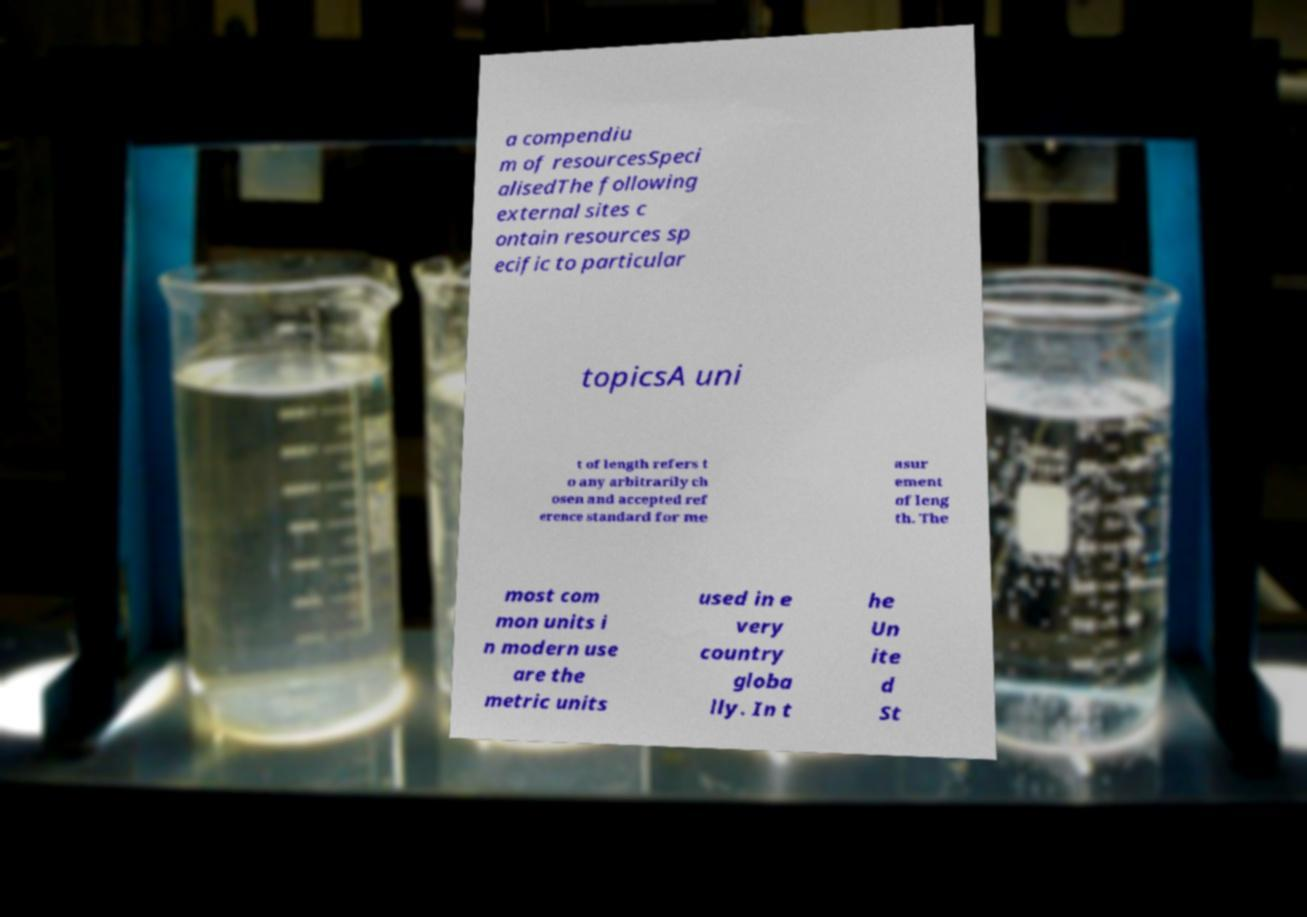What messages or text are displayed in this image? I need them in a readable, typed format. a compendiu m of resourcesSpeci alisedThe following external sites c ontain resources sp ecific to particular topicsA uni t of length refers t o any arbitrarily ch osen and accepted ref erence standard for me asur ement of leng th. The most com mon units i n modern use are the metric units used in e very country globa lly. In t he Un ite d St 